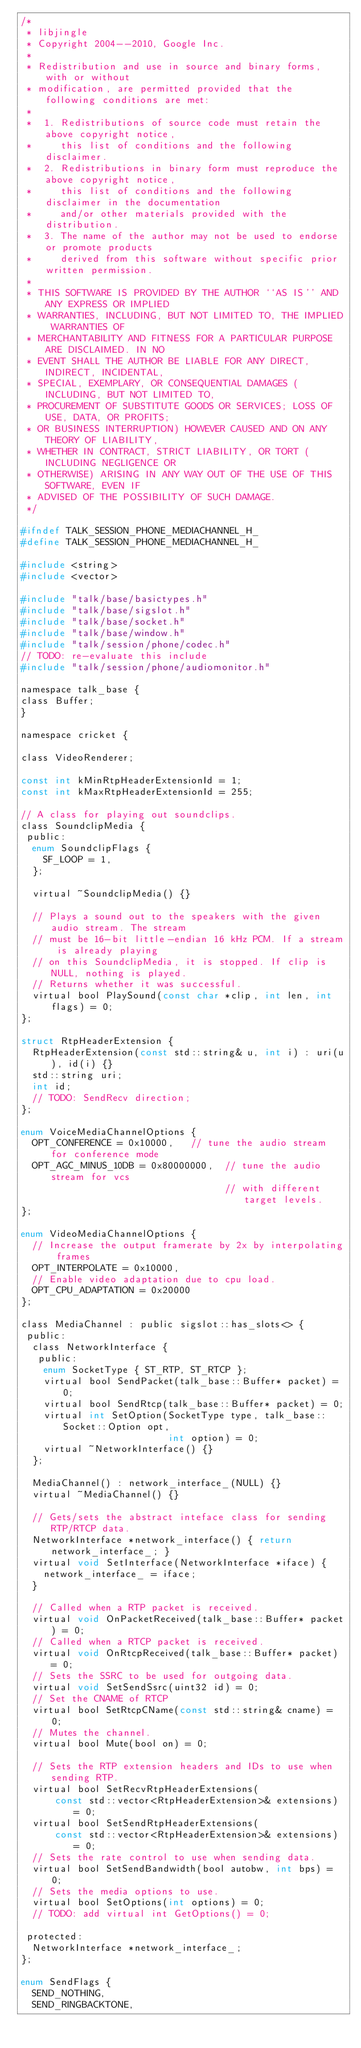<code> <loc_0><loc_0><loc_500><loc_500><_C_>/*
 * libjingle
 * Copyright 2004--2010, Google Inc.
 *
 * Redistribution and use in source and binary forms, with or without
 * modification, are permitted provided that the following conditions are met:
 *
 *  1. Redistributions of source code must retain the above copyright notice,
 *     this list of conditions and the following disclaimer.
 *  2. Redistributions in binary form must reproduce the above copyright notice,
 *     this list of conditions and the following disclaimer in the documentation
 *     and/or other materials provided with the distribution.
 *  3. The name of the author may not be used to endorse or promote products
 *     derived from this software without specific prior written permission.
 *
 * THIS SOFTWARE IS PROVIDED BY THE AUTHOR ``AS IS'' AND ANY EXPRESS OR IMPLIED
 * WARRANTIES, INCLUDING, BUT NOT LIMITED TO, THE IMPLIED WARRANTIES OF
 * MERCHANTABILITY AND FITNESS FOR A PARTICULAR PURPOSE ARE DISCLAIMED. IN NO
 * EVENT SHALL THE AUTHOR BE LIABLE FOR ANY DIRECT, INDIRECT, INCIDENTAL,
 * SPECIAL, EXEMPLARY, OR CONSEQUENTIAL DAMAGES (INCLUDING, BUT NOT LIMITED TO,
 * PROCUREMENT OF SUBSTITUTE GOODS OR SERVICES; LOSS OF USE, DATA, OR PROFITS;
 * OR BUSINESS INTERRUPTION) HOWEVER CAUSED AND ON ANY THEORY OF LIABILITY,
 * WHETHER IN CONTRACT, STRICT LIABILITY, OR TORT (INCLUDING NEGLIGENCE OR
 * OTHERWISE) ARISING IN ANY WAY OUT OF THE USE OF THIS SOFTWARE, EVEN IF
 * ADVISED OF THE POSSIBILITY OF SUCH DAMAGE.
 */

#ifndef TALK_SESSION_PHONE_MEDIACHANNEL_H_
#define TALK_SESSION_PHONE_MEDIACHANNEL_H_

#include <string>
#include <vector>

#include "talk/base/basictypes.h"
#include "talk/base/sigslot.h"
#include "talk/base/socket.h"
#include "talk/base/window.h"
#include "talk/session/phone/codec.h"
// TODO: re-evaluate this include
#include "talk/session/phone/audiomonitor.h"

namespace talk_base {
class Buffer;
}

namespace cricket {

class VideoRenderer;

const int kMinRtpHeaderExtensionId = 1;
const int kMaxRtpHeaderExtensionId = 255;

// A class for playing out soundclips.
class SoundclipMedia {
 public:
  enum SoundclipFlags {
    SF_LOOP = 1,
  };

  virtual ~SoundclipMedia() {}

  // Plays a sound out to the speakers with the given audio stream. The stream
  // must be 16-bit little-endian 16 kHz PCM. If a stream is already playing
  // on this SoundclipMedia, it is stopped. If clip is NULL, nothing is played.
  // Returns whether it was successful.
  virtual bool PlaySound(const char *clip, int len, int flags) = 0;
};

struct RtpHeaderExtension {
  RtpHeaderExtension(const std::string& u, int i) : uri(u), id(i) {}
  std::string uri;
  int id;
  // TODO: SendRecv direction;
};

enum VoiceMediaChannelOptions {
  OPT_CONFERENCE = 0x10000,   // tune the audio stream for conference mode
  OPT_AGC_MINUS_10DB = 0x80000000,  // tune the audio stream for vcs
                                    // with different target levels.
};

enum VideoMediaChannelOptions {
  // Increase the output framerate by 2x by interpolating frames
  OPT_INTERPOLATE = 0x10000,
  // Enable video adaptation due to cpu load.
  OPT_CPU_ADAPTATION = 0x20000
};

class MediaChannel : public sigslot::has_slots<> {
 public:
  class NetworkInterface {
   public:
    enum SocketType { ST_RTP, ST_RTCP };
    virtual bool SendPacket(talk_base::Buffer* packet) = 0;
    virtual bool SendRtcp(talk_base::Buffer* packet) = 0;
    virtual int SetOption(SocketType type, talk_base::Socket::Option opt,
                          int option) = 0;
    virtual ~NetworkInterface() {}
  };

  MediaChannel() : network_interface_(NULL) {}
  virtual ~MediaChannel() {}

  // Gets/sets the abstract inteface class for sending RTP/RTCP data.
  NetworkInterface *network_interface() { return network_interface_; }
  virtual void SetInterface(NetworkInterface *iface) {
    network_interface_ = iface;
  }

  // Called when a RTP packet is received.
  virtual void OnPacketReceived(talk_base::Buffer* packet) = 0;
  // Called when a RTCP packet is received.
  virtual void OnRtcpReceived(talk_base::Buffer* packet) = 0;
  // Sets the SSRC to be used for outgoing data.
  virtual void SetSendSsrc(uint32 id) = 0;
  // Set the CNAME of RTCP
  virtual bool SetRtcpCName(const std::string& cname) = 0;
  // Mutes the channel.
  virtual bool Mute(bool on) = 0;

  // Sets the RTP extension headers and IDs to use when sending RTP.
  virtual bool SetRecvRtpHeaderExtensions(
      const std::vector<RtpHeaderExtension>& extensions) = 0;
  virtual bool SetSendRtpHeaderExtensions(
      const std::vector<RtpHeaderExtension>& extensions) = 0;
  // Sets the rate control to use when sending data.
  virtual bool SetSendBandwidth(bool autobw, int bps) = 0;
  // Sets the media options to use.
  virtual bool SetOptions(int options) = 0;
  // TODO: add virtual int GetOptions() = 0;

 protected:
  NetworkInterface *network_interface_;
};

enum SendFlags {
  SEND_NOTHING,
  SEND_RINGBACKTONE,</code> 